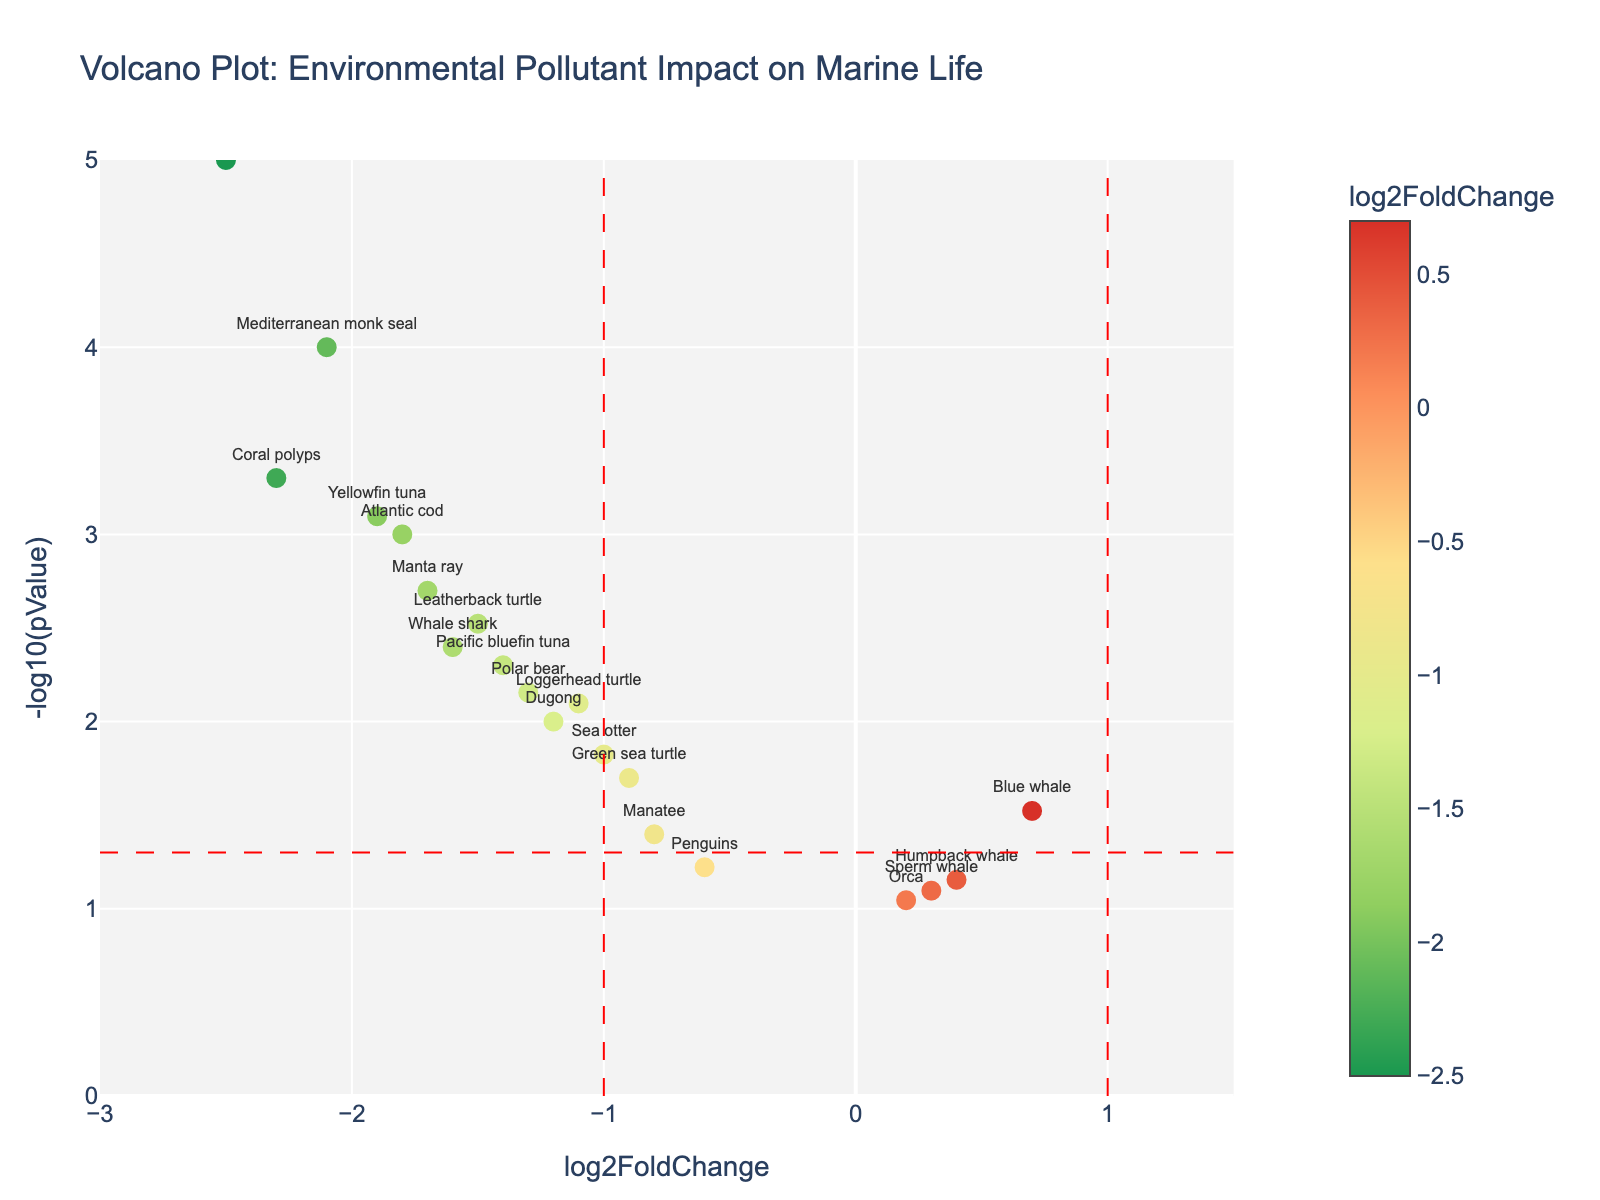What's the title of the figure? The title is typically positioned at the top of the plot to provide an overview of what the figure represents.
Answer: Volcano Plot: Environmental Pollutant Impact on Marine Life How many species show a statistically significant change (p-value < 0.05)? To determine statistical significance, look for species above the horizontal red dashed line (since -log10(0.05) is about 1.3) on the plot. Count the data points above this threshold.
Answer: 15 species Which species shows the largest decrease in population? The largest decrease in population is indicated by the most negative log2FoldChange value. Identify the data point that is furthest to the left on the x-axis.
Answer: Staghorn coral What are the log2FoldChange and -log10(pValue) for the Green sea turtle? Locate the data point labeled "Green sea turtle" on the plot, reading its coordinates. The x-coordinate represents log2FoldChange, and the y-coordinate represents -log10(pValue).
Answer: log2FoldChange: -0.9, -log10(pValue): 1.7 Is the population change of the Orca statistically significant? A population change is statistically significant if its p-value is less than 0.05, represented as being above the horizontal red dashed line on the y-axis. Locate the "Orca" on the plot to see if it meets these criteria.
Answer: No Which species have a log2FoldChange value between -1.5 and -1.0? Identify the data points on the plot whose x-coordinates fall between -1.5 and -1.0 and read their labels.
Answer: Dugong, Green sea turtle, Loggerhead turtle, Polar bear, Sea otter Among the species with a statistically significant change, which has the least amount of population decrease? First identify species with a significant change (above the horizontal red dashed line due to p-value < 0.05). Among these, find the species with the highest log2FoldChange value on the negative side.
Answer: Manatee How does the change in the population of the Humpback whale compare to the Blue whale? Look for the data points labeled "Humpback whale" and "Blue whale." Compare their log2FoldChange values (x-coordinates).
Answer: Humpback whale has a smaller increase What threshold marks the p-value of 0.05 on the plot? The threshold is indicated by a horizontal red dashed line. Since -log10(0.05) is approximately 1.3, this line intersects the y-axis at 1.3.
Answer: -log10(pValue) = 1.3 